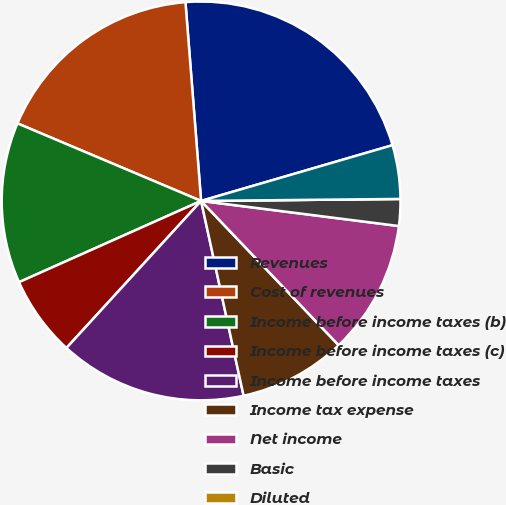Convert chart to OTSL. <chart><loc_0><loc_0><loc_500><loc_500><pie_chart><fcel>Revenues<fcel>Cost of revenues<fcel>Income before income taxes (b)<fcel>Income before income taxes (c)<fcel>Income before income taxes<fcel>Income tax expense<fcel>Net income<fcel>Basic<fcel>Diluted<fcel>Effect of dilutive securities<nl><fcel>21.74%<fcel>17.39%<fcel>13.04%<fcel>6.52%<fcel>15.22%<fcel>8.7%<fcel>10.87%<fcel>2.17%<fcel>0.0%<fcel>4.35%<nl></chart> 